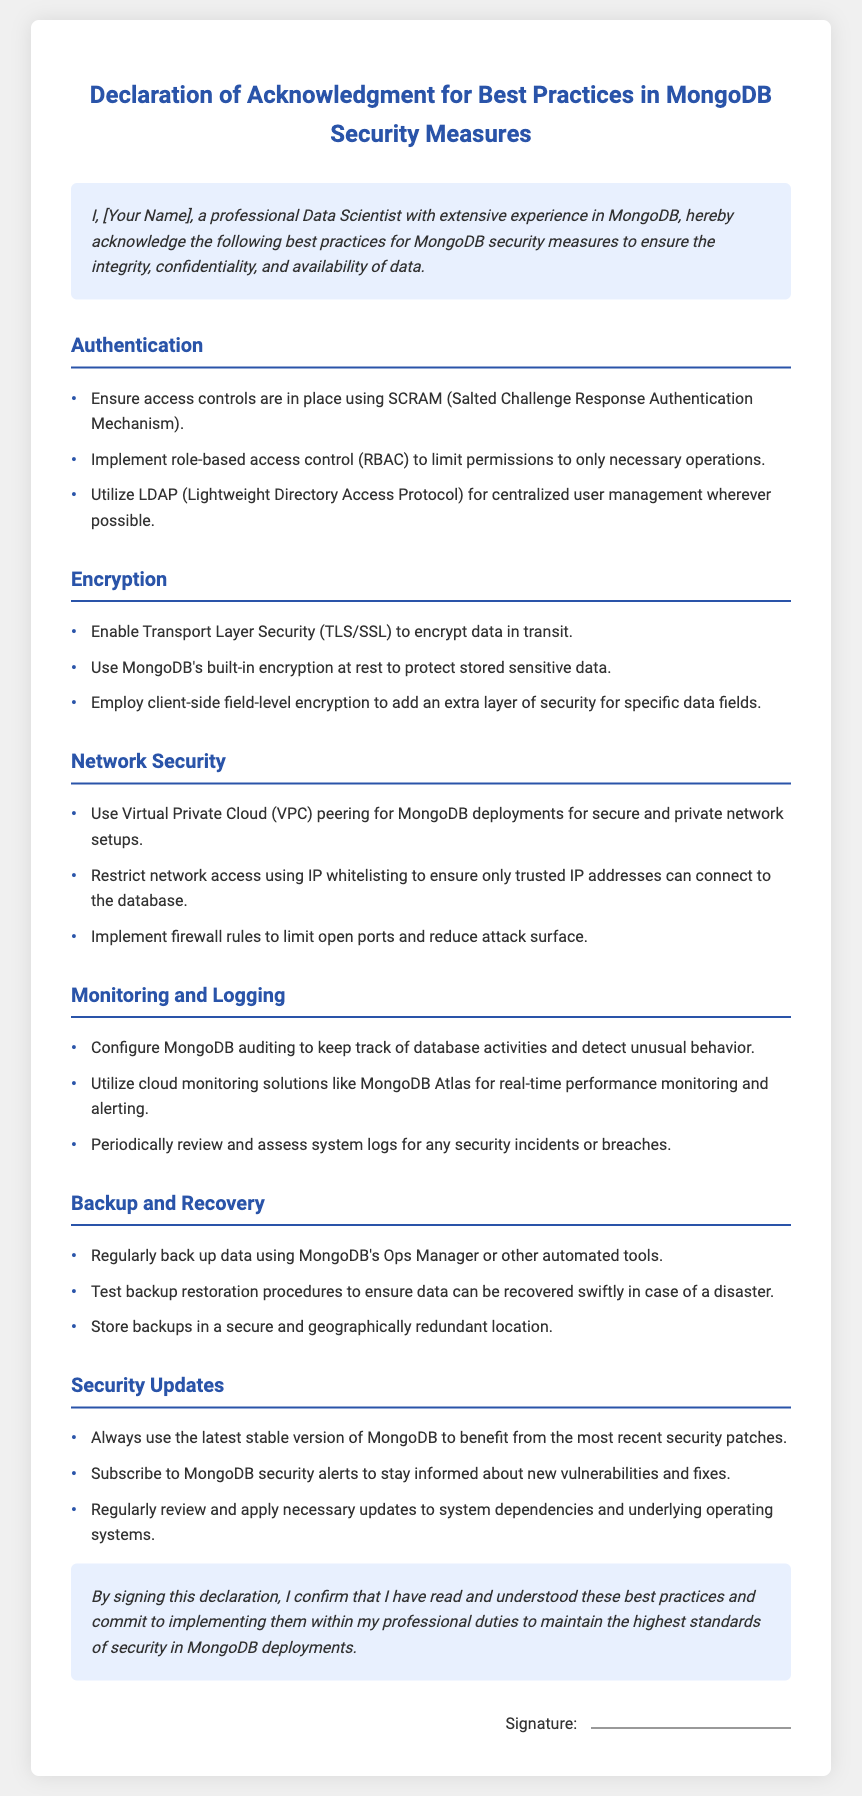What is the title of the document? The title is stated clearly at the top of the document, specifying the content of the declaration.
Answer: Declaration of Acknowledgment for Best Practices in MongoDB Security Measures Who is the author of the declaration? The author's name is indicated in the introductory header of the document.
Answer: [Your Name] What are the three main security areas covered in the best practices? The document lists five main areas of focus for MongoDB security, the specific areas can be selected from these.
Answer: Authentication, Encryption, Network Security What does RBAC stand for? The term RBAC is defined in the context of access control measures, specifying its full form.
Answer: Role-Based Access Control What is used for encrypting data in transit? The document specifies a particular standard used for securing data during transmission.
Answer: TLS/SSL How frequently should backups be conducted according to the best practices? The document emphasizes the importance of regular backups, but does not specify a frequency.
Answer: Regularly What should be done to ensure data can be recovered swiftly? This action is highlighted under the backup and recovery section of the document.
Answer: Test backup restoration procedures What is the purpose of MongoDB auditing? The document mentions this to highlight its role in monitoring database activity.
Answer: Track database activities What action confirms understanding and commitment according to the declaration? The document states that signing the declaration serves a specific purpose in confirming acknowledgment and commitment.
Answer: Signing 